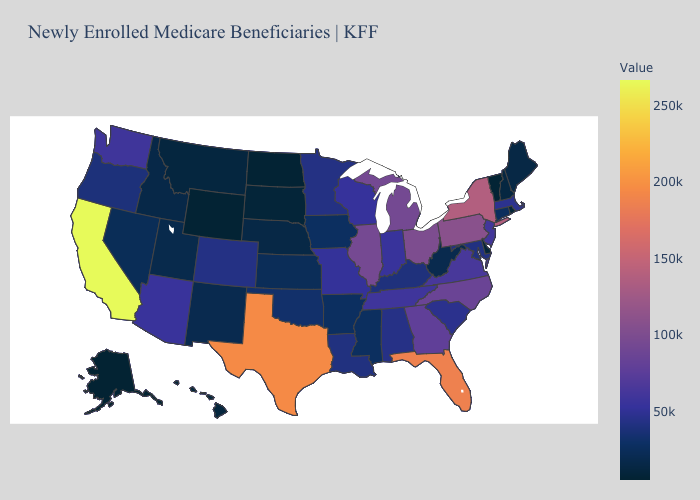Does Colorado have the lowest value in the West?
Give a very brief answer. No. Is the legend a continuous bar?
Short answer required. Yes. Does New York have the highest value in the Northeast?
Quick response, please. Yes. Which states have the lowest value in the MidWest?
Keep it brief. North Dakota. Does the map have missing data?
Short answer required. No. Which states have the lowest value in the South?
Short answer required. Delaware. Does South Dakota have the lowest value in the MidWest?
Keep it brief. No. Which states have the highest value in the USA?
Answer briefly. California. Does the map have missing data?
Be succinct. No. Which states have the lowest value in the USA?
Short answer required. Alaska. 